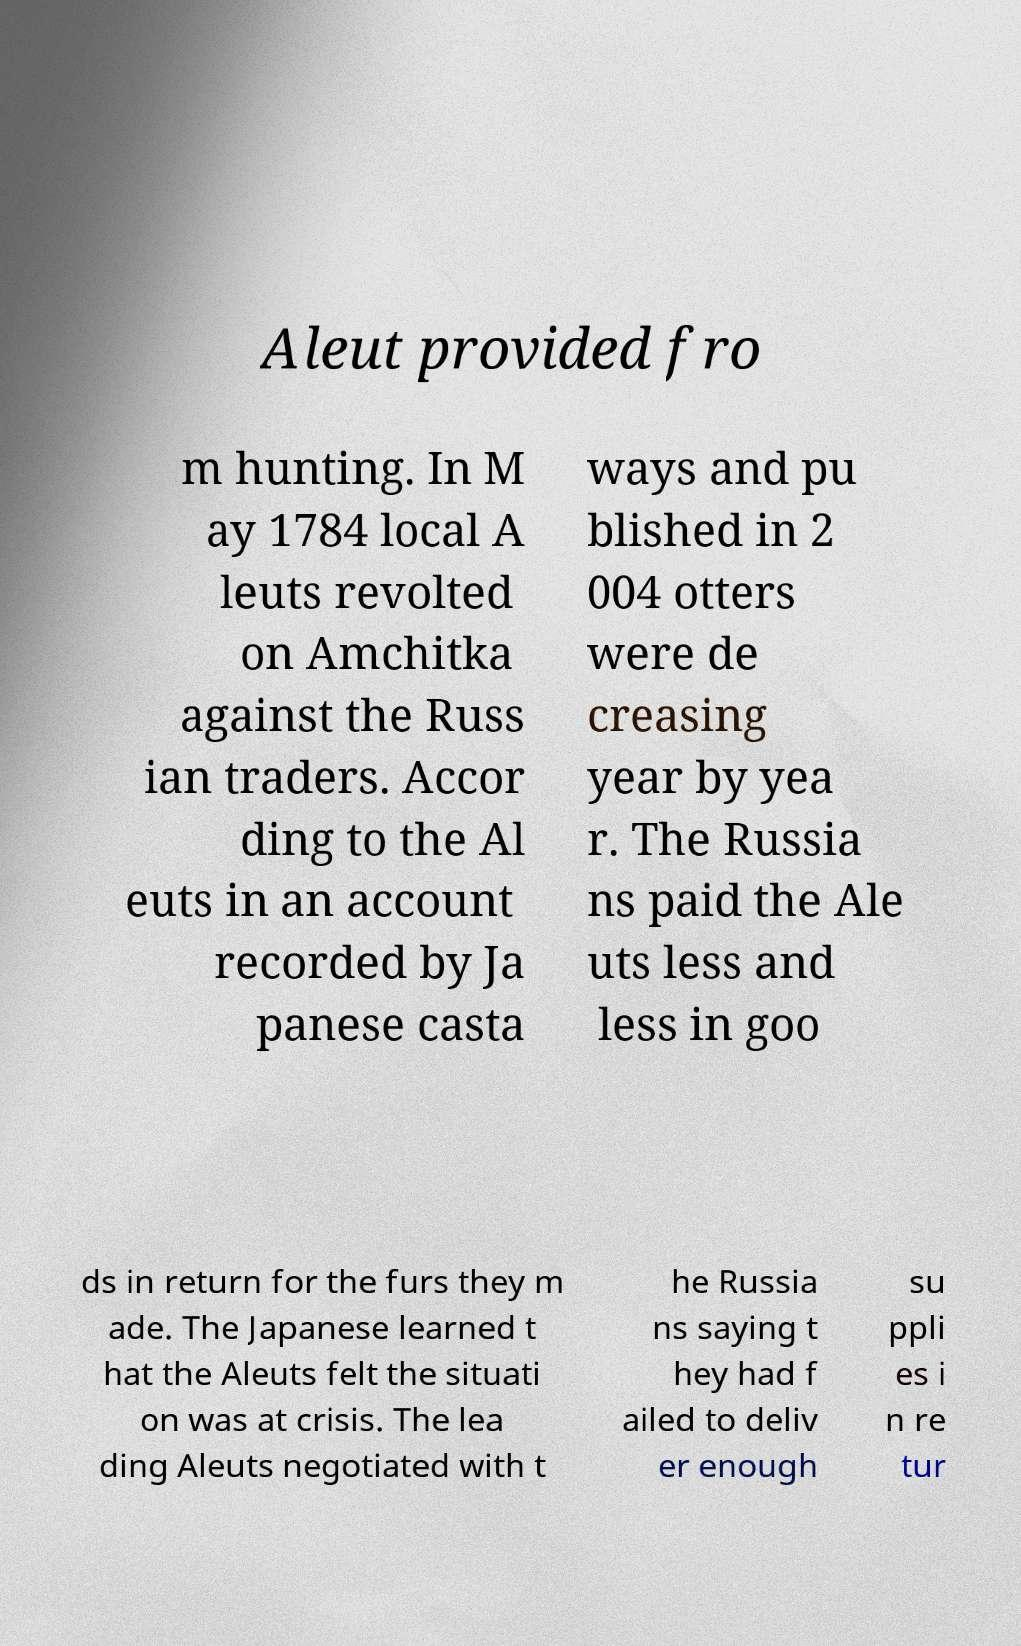Please read and relay the text visible in this image. What does it say? Aleut provided fro m hunting. In M ay 1784 local A leuts revolted on Amchitka against the Russ ian traders. Accor ding to the Al euts in an account recorded by Ja panese casta ways and pu blished in 2 004 otters were de creasing year by yea r. The Russia ns paid the Ale uts less and less in goo ds in return for the furs they m ade. The Japanese learned t hat the Aleuts felt the situati on was at crisis. The lea ding Aleuts negotiated with t he Russia ns saying t hey had f ailed to deliv er enough su ppli es i n re tur 